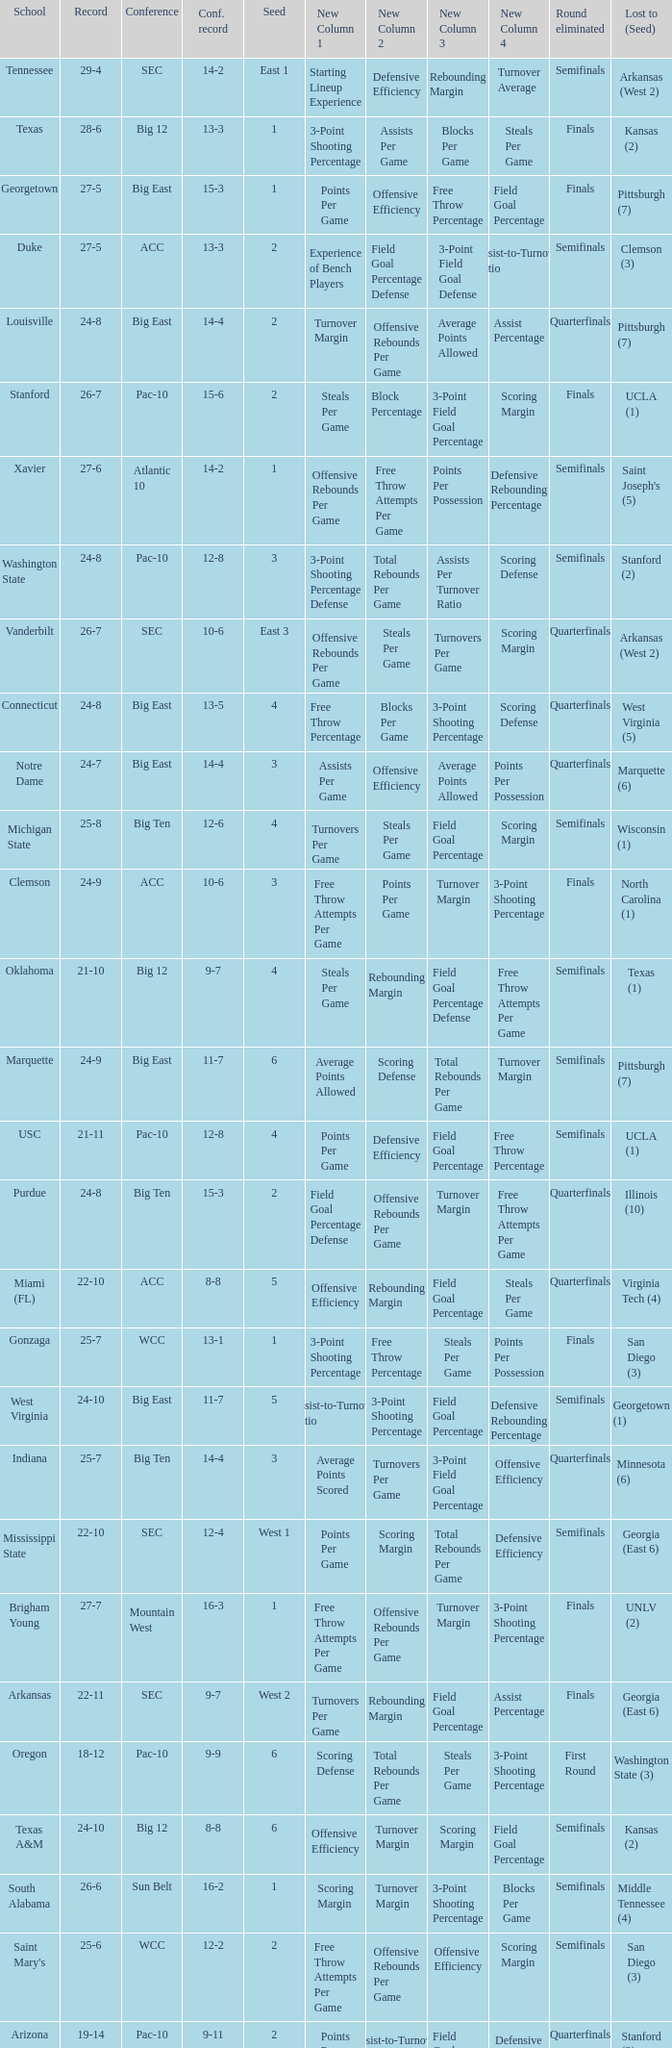Name the school where conference record is 12-6 Michigan State. 